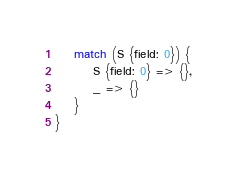<code> <loc_0><loc_0><loc_500><loc_500><_Rust_>    match (S {field: 0}) {
        S {field: 0} => {},
        _ => {}
    }
}</code> 